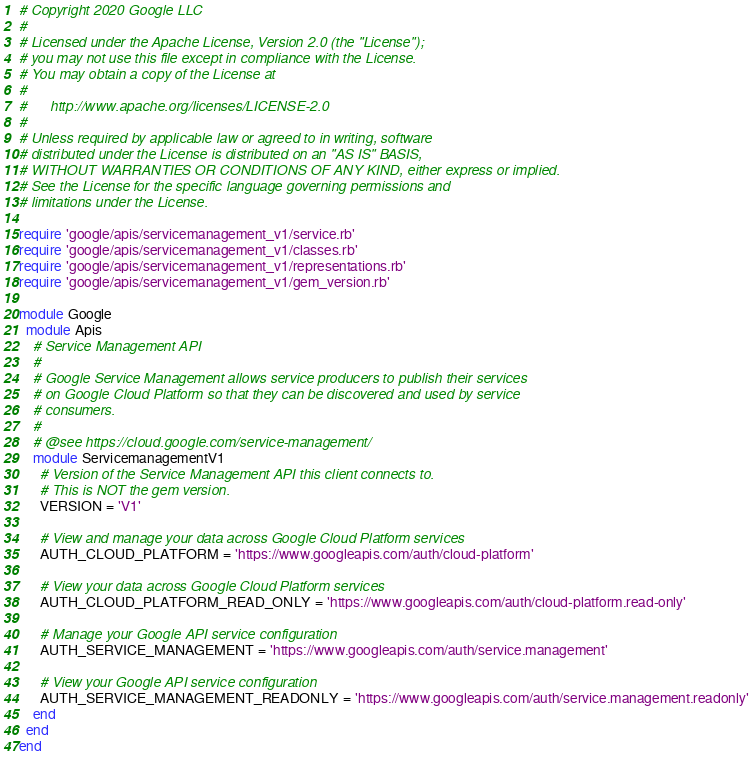Convert code to text. <code><loc_0><loc_0><loc_500><loc_500><_Ruby_># Copyright 2020 Google LLC
#
# Licensed under the Apache License, Version 2.0 (the "License");
# you may not use this file except in compliance with the License.
# You may obtain a copy of the License at
#
#      http://www.apache.org/licenses/LICENSE-2.0
#
# Unless required by applicable law or agreed to in writing, software
# distributed under the License is distributed on an "AS IS" BASIS,
# WITHOUT WARRANTIES OR CONDITIONS OF ANY KIND, either express or implied.
# See the License for the specific language governing permissions and
# limitations under the License.

require 'google/apis/servicemanagement_v1/service.rb'
require 'google/apis/servicemanagement_v1/classes.rb'
require 'google/apis/servicemanagement_v1/representations.rb'
require 'google/apis/servicemanagement_v1/gem_version.rb'

module Google
  module Apis
    # Service Management API
    #
    # Google Service Management allows service producers to publish their services
    # on Google Cloud Platform so that they can be discovered and used by service
    # consumers.
    #
    # @see https://cloud.google.com/service-management/
    module ServicemanagementV1
      # Version of the Service Management API this client connects to.
      # This is NOT the gem version.
      VERSION = 'V1'

      # View and manage your data across Google Cloud Platform services
      AUTH_CLOUD_PLATFORM = 'https://www.googleapis.com/auth/cloud-platform'

      # View your data across Google Cloud Platform services
      AUTH_CLOUD_PLATFORM_READ_ONLY = 'https://www.googleapis.com/auth/cloud-platform.read-only'

      # Manage your Google API service configuration
      AUTH_SERVICE_MANAGEMENT = 'https://www.googleapis.com/auth/service.management'

      # View your Google API service configuration
      AUTH_SERVICE_MANAGEMENT_READONLY = 'https://www.googleapis.com/auth/service.management.readonly'
    end
  end
end
</code> 